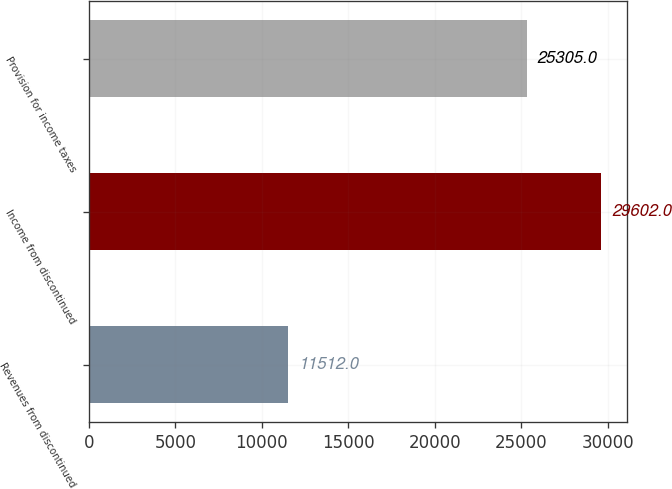Convert chart. <chart><loc_0><loc_0><loc_500><loc_500><bar_chart><fcel>Revenues from discontinued<fcel>Income from discontinued<fcel>Provision for income taxes<nl><fcel>11512<fcel>29602<fcel>25305<nl></chart> 